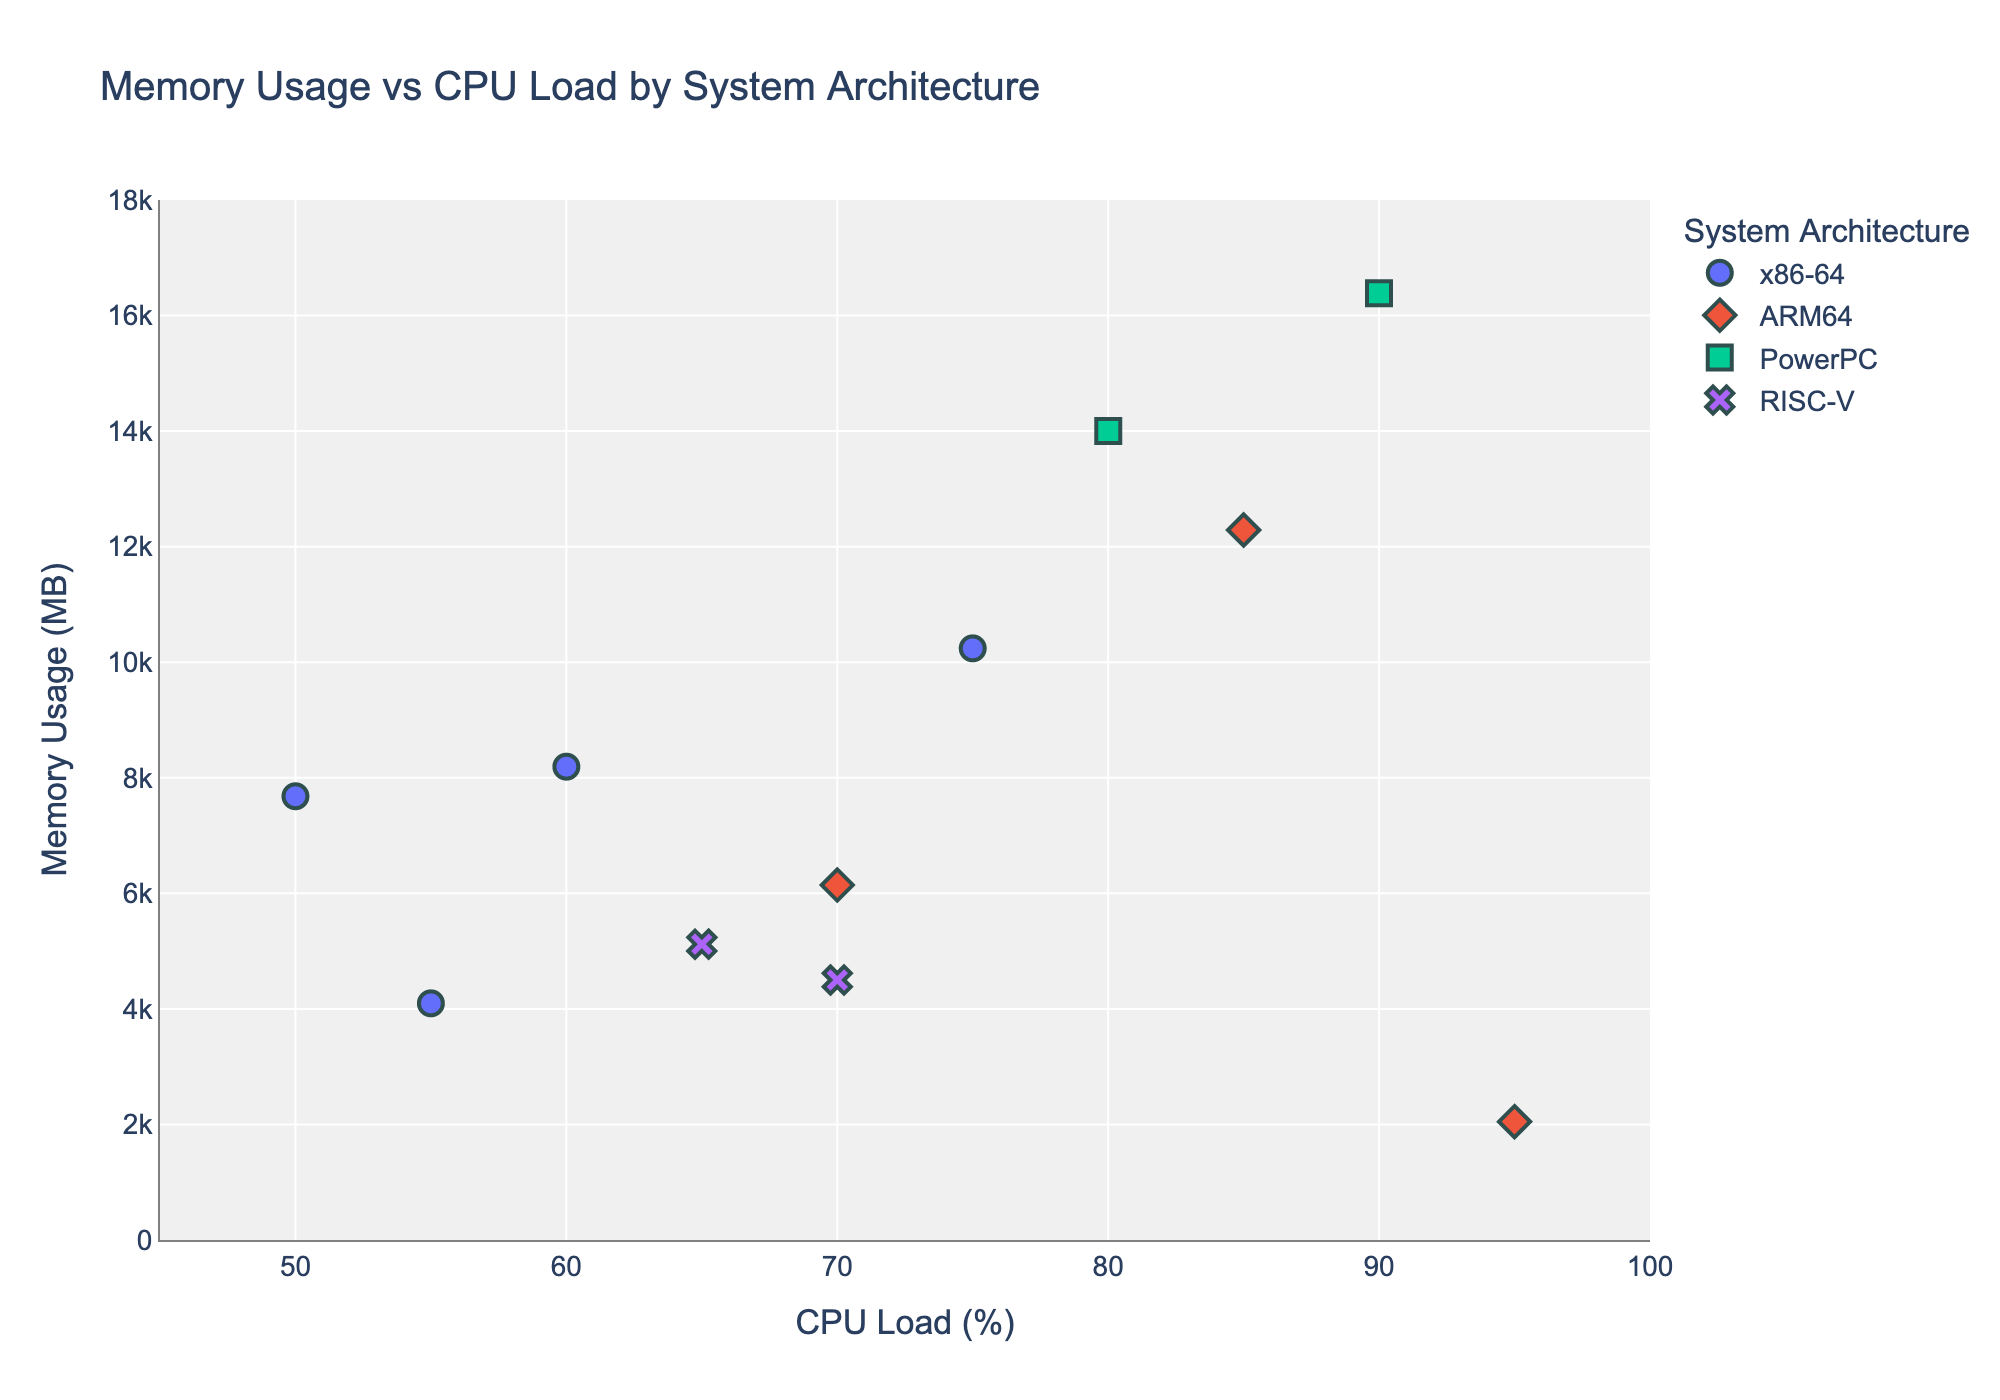What's the title of the figure? The title is located at the top center of the plot area. It is often used to describe the main purpose or summary of the graph. In this figure, the title specifically focuses on two key variables, Memory Usage and CPU Load, classified by System Architecture.
Answer: Memory Usage vs CPU Load by System Architecture How many data points are plotted for the 'x86-64' architecture? Each data point is represented by a different marker on the scatter plot, categorized by color and symbol based on the architecture. To count the 'x86-64' architecture data points, locate markers with the same color/symbol designated for 'x86-64' and count them. There are data points for 'Apache_Server_1', 'Nginx_Server_2', 'Tomcat_Server_3', and 'Apache_Server_4'.
Answer: 4 Which system architecture has the highest CPU Load percentage? Observe the x-axis labeled 'CPU Load (%)' and find the rightmost data point, which corresponds to the highest CPU Load percentage. Then, match the color/symbol indicating the system architecture. The highest CPU Load is 95%, corresponding to 'AWS_EC2_Inst_C' under ARM64.
Answer: ARM64 What is the CPU Load and Memory Usage of 'IBM_Server_X'? Use the hover feature to identify the data point representing 'IBM_Server_X' or locate it based on known values. The specific values are written next to the point or accessible on hover. Here, 'IBM_Server_X' shows a CPU Load of 90% and Memory Usage of 16384 MB.
Answer: 90%, 16384 MB Which server shows the minimum memory usage? Look for the lowest value along the y-axis labeled 'Memory Usage (MB)' and identify the corresponding data point's server by its color/symbol and hover data. The minimum memory usage is at 2048 MB, which belongs to 'AWS_EC2_Inst_C' under ARM64.
Answer: AWS_EC2_Inst_C How does the Memory Usage of 'IBM_Server_Y' compare to 'Research_Server_2'? First, locate the data points for 'IBM_Server_Y' and 'Research_Server_2' by their hover data or visual markers. Then, compare their y-axis values directly to determine which has higher memory usage. 'IBM_Server_Y' has 14000 MB while 'Research_Server_2' has 4500 MB.
Answer: 'IBM_Server_Y' has higher memory usage than 'Research_Server_2' Which system architecture's servers show the most varied CPU Load percentages? Examine the spread along the x-axis for each architecture's data points (indicated by color/symbols). Identify the architecture with the widest range of CPU Load percentages. ARM64 servers span from 70% to 95%, showing the most variation.
Answer: ARM64 What is the average CPU Load percentage for ARM64 servers? Locate all ARM64 data points and note their CPU Loads: 85, 70, and 95. Add these values together and divide by the count of ARM64 servers to find the average. (85 + 70 + 95) / 3 = 83.33
Answer: 83.33 Which server has a CPU Load of 75% and what is its Memory Usage? Find the data point at 75% on the x-axis and check its hover data for the server name and corresponding y-axis value. 'Apache_Server_1' has a CPU Load of 75% and Memory Usage of 10240 MB.
Answer: 'Apache_Server_1' with 10240 MB How many data points are plotted for each system architecture? Count the data points for each architecture based on their distinct color/symbol. Summarize these counts for 'x86-64', 'ARM64', 'PowerPC', and 'RISC-V'. 'x86-64' has 4, 'ARM64' has 3, 'PowerPC' has 2, and 'RISC-V' has 2 points.
Answer: x86-64: 4, ARM64: 3, PowerPC: 2, RISC-V: 2 